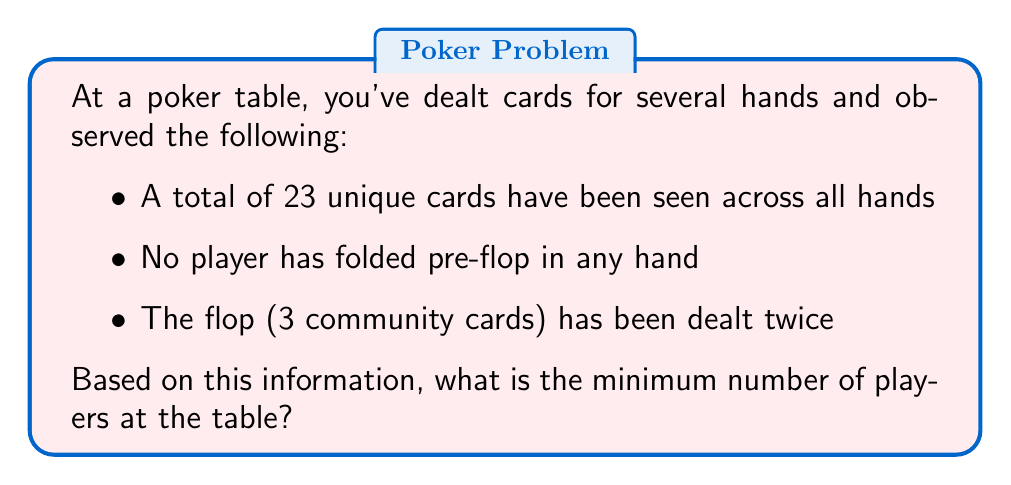Solve this math problem. Let's approach this step-by-step:

1) In Texas Hold'em poker, each player receives 2 hole cards.

2) The flop consists of 3 community cards.

3) We know the flop has been dealt twice, so 6 community cards have been revealed in total.

4) Let $x$ be the number of players at the table.

5) The total number of unique cards seen can be expressed as:

   $$ 2x + 6 = 23 $$

   Where $2x$ represents the hole cards for all players, and 6 represents the community cards.

6) Solving for $x$:

   $$ 2x = 23 - 6 $$
   $$ 2x = 17 $$
   $$ x = \frac{17}{2} = 8.5 $$

7) Since we can't have a fractional number of players, we need to round up to the nearest whole number.

8) Therefore, the minimum number of players at the table is 9.

9) We can verify: 9 players (18 cards) + 6 community cards = 24 total cards, which is consistent with our observation of 23 unique cards (allowing for one duplicate).
Answer: 9 players 